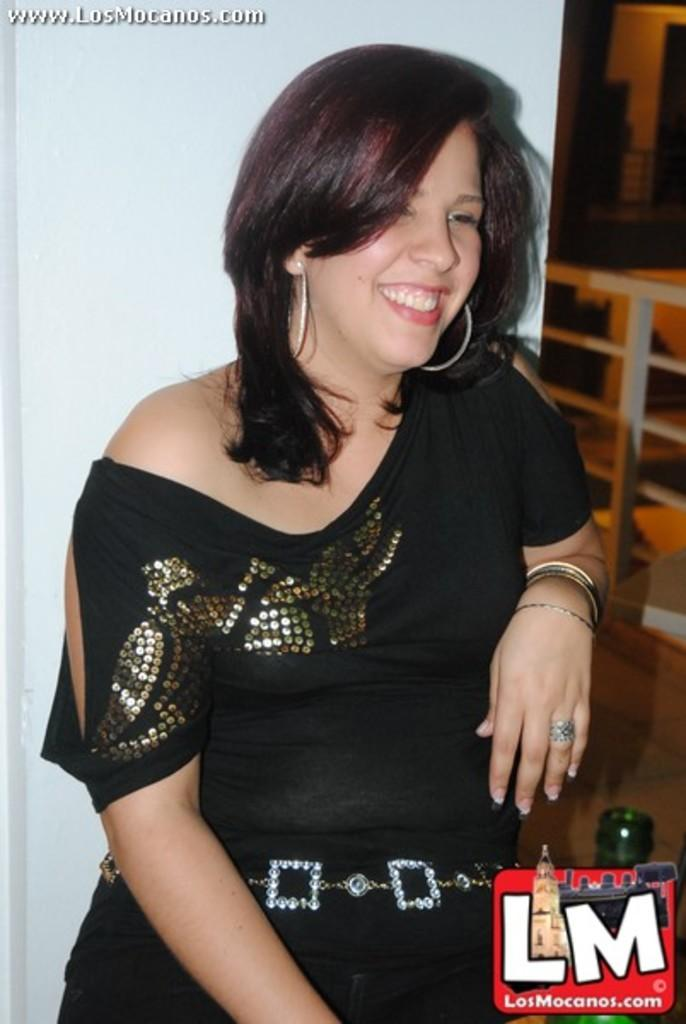Who is present in the image? There is a woman in the image. What is the woman's expression? The woman is smiling. What object can be seen in the image? There is a bottle in the image. Is there any text or symbol in the image? Yes, there is a logo in the image. What color is the background of the image? The background of the image is white. Can you see a flock of birds in the image? No, there are no birds or a flock of birds present in the image. 